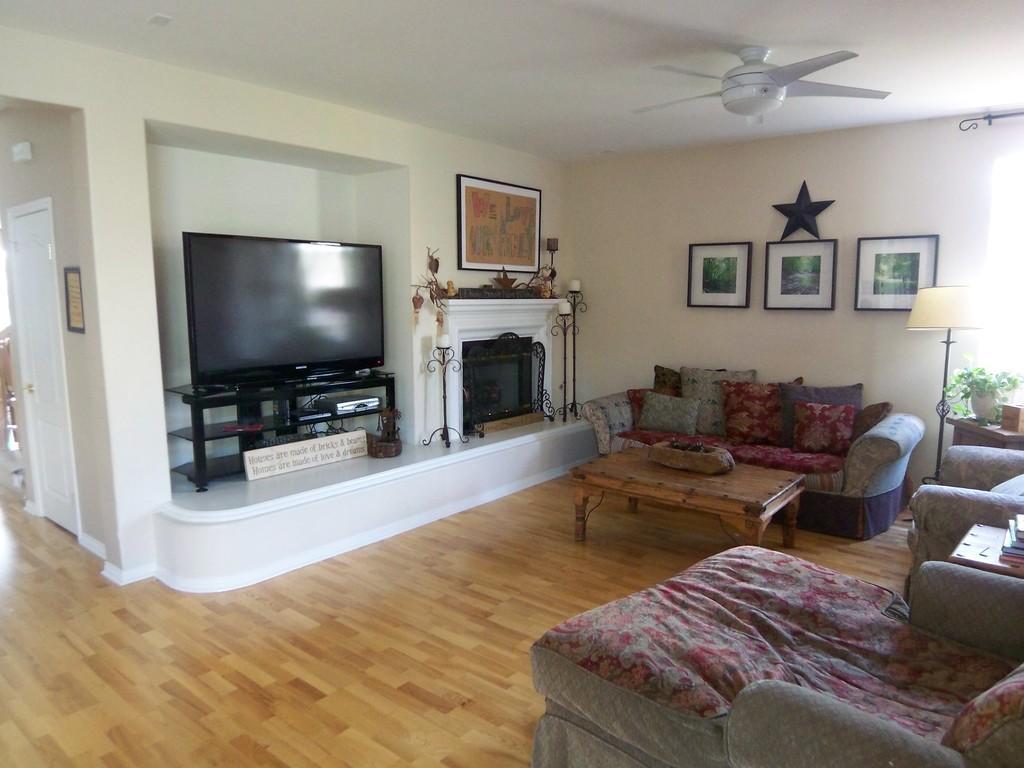Could you give a brief overview of what you see in this image? In this picture we can see a room with sofa pillows on it and table and in the background we can see wall with frames here television on table and bedside to this we have a door and on right side we can see lamp, flower pot with plant in it and placed on a table along with books. 